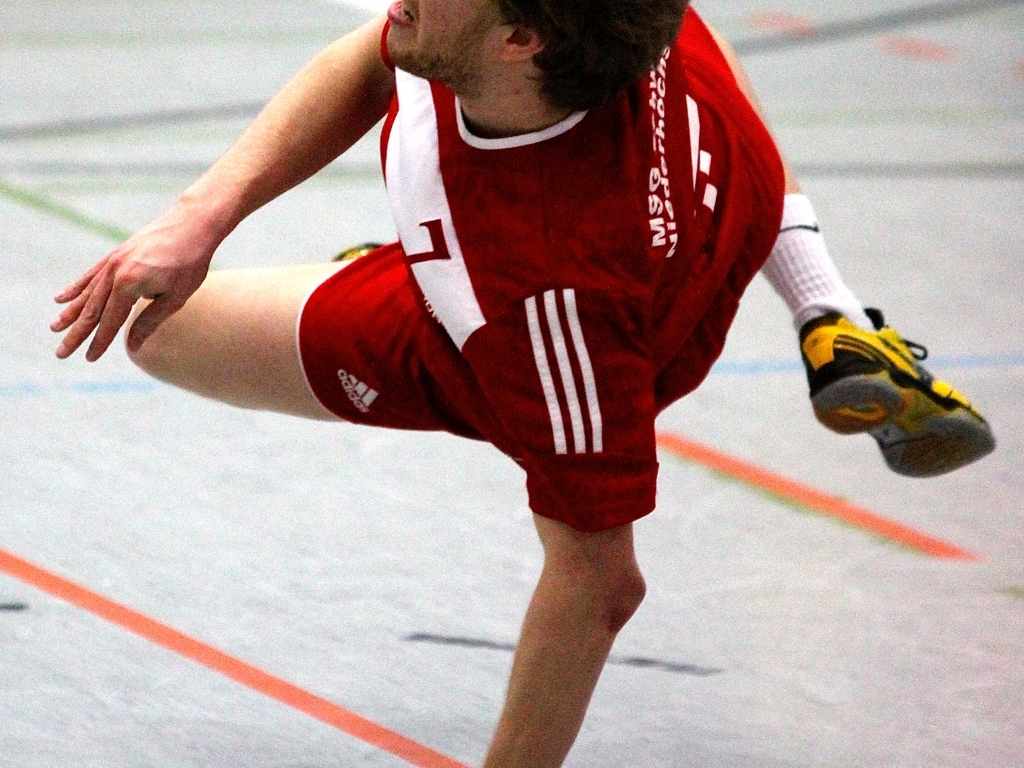What sport is being played in this image? The athlete is dressed in sportswear that suggests an indoor sport, possibly handball, given the attire and the sneaker design. 